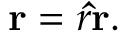Convert formula to latex. <formula><loc_0><loc_0><loc_500><loc_500>r = r \hat { r } .</formula> 